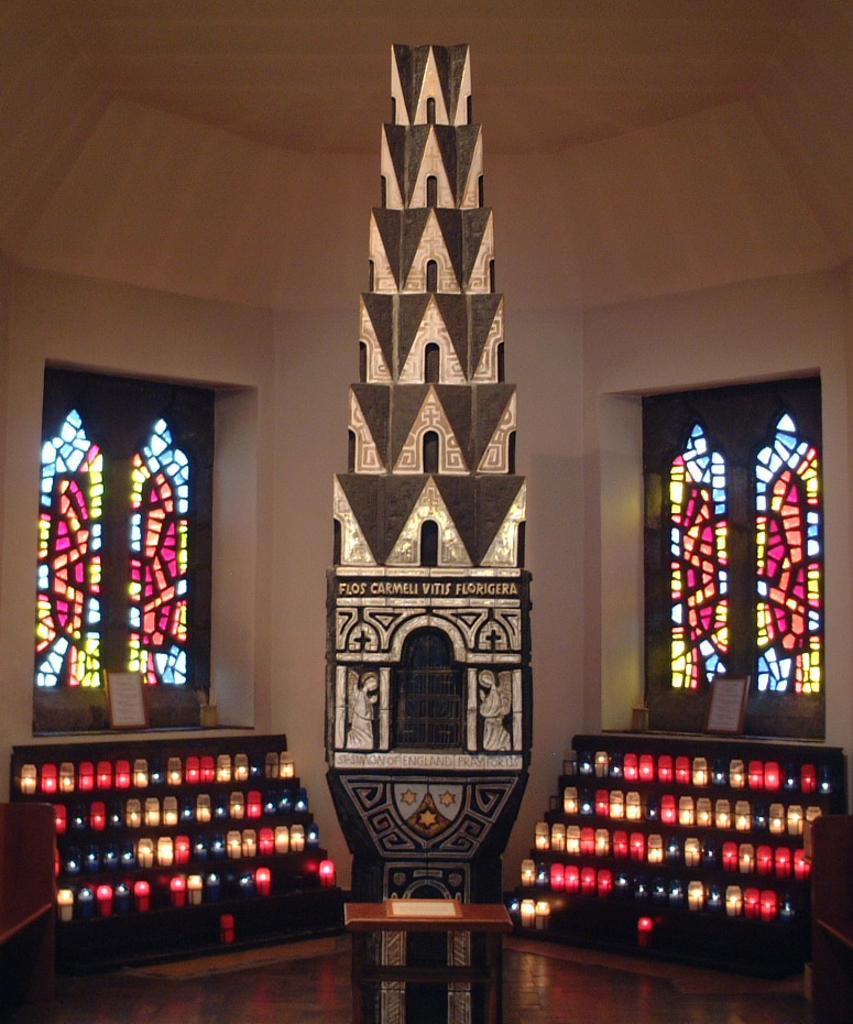Describe this image in one or two sentences. In the picture we can see lights, a table, architecture, stained glass windows and the wall in the background. 